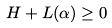<formula> <loc_0><loc_0><loc_500><loc_500>H + L ( \alpha ) \geq 0</formula> 